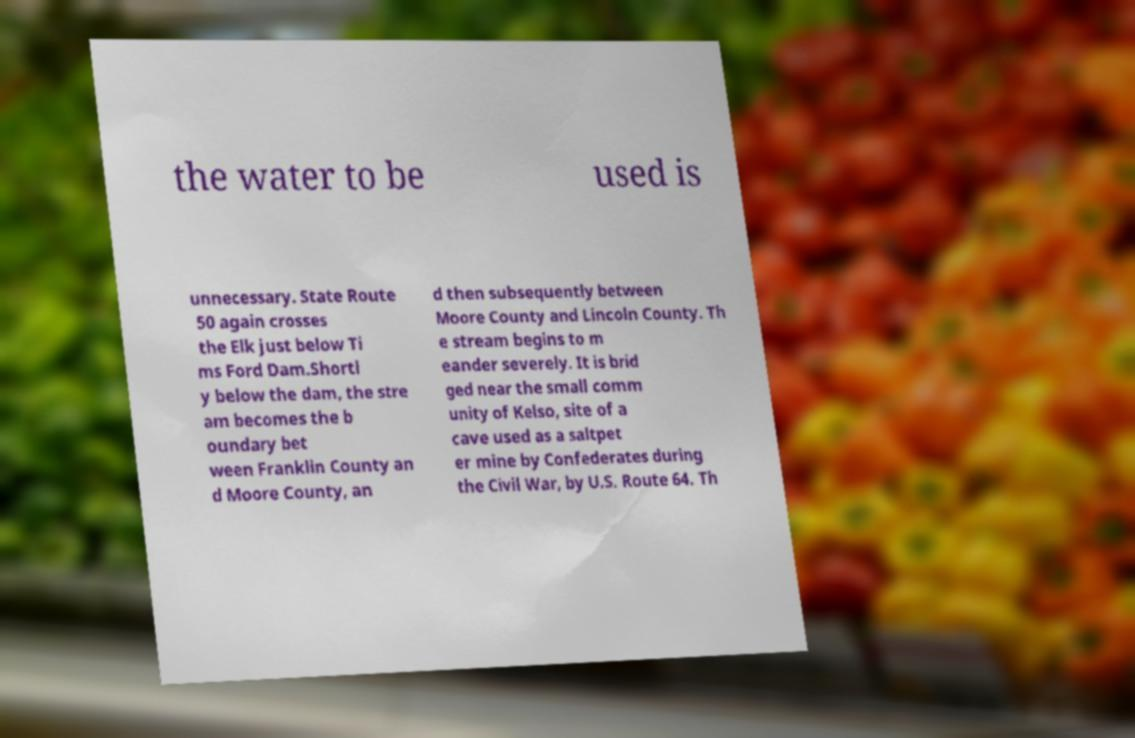Can you accurately transcribe the text from the provided image for me? the water to be used is unnecessary. State Route 50 again crosses the Elk just below Ti ms Ford Dam.Shortl y below the dam, the stre am becomes the b oundary bet ween Franklin County an d Moore County, an d then subsequently between Moore County and Lincoln County. Th e stream begins to m eander severely. It is brid ged near the small comm unity of Kelso, site of a cave used as a saltpet er mine by Confederates during the Civil War, by U.S. Route 64. Th 